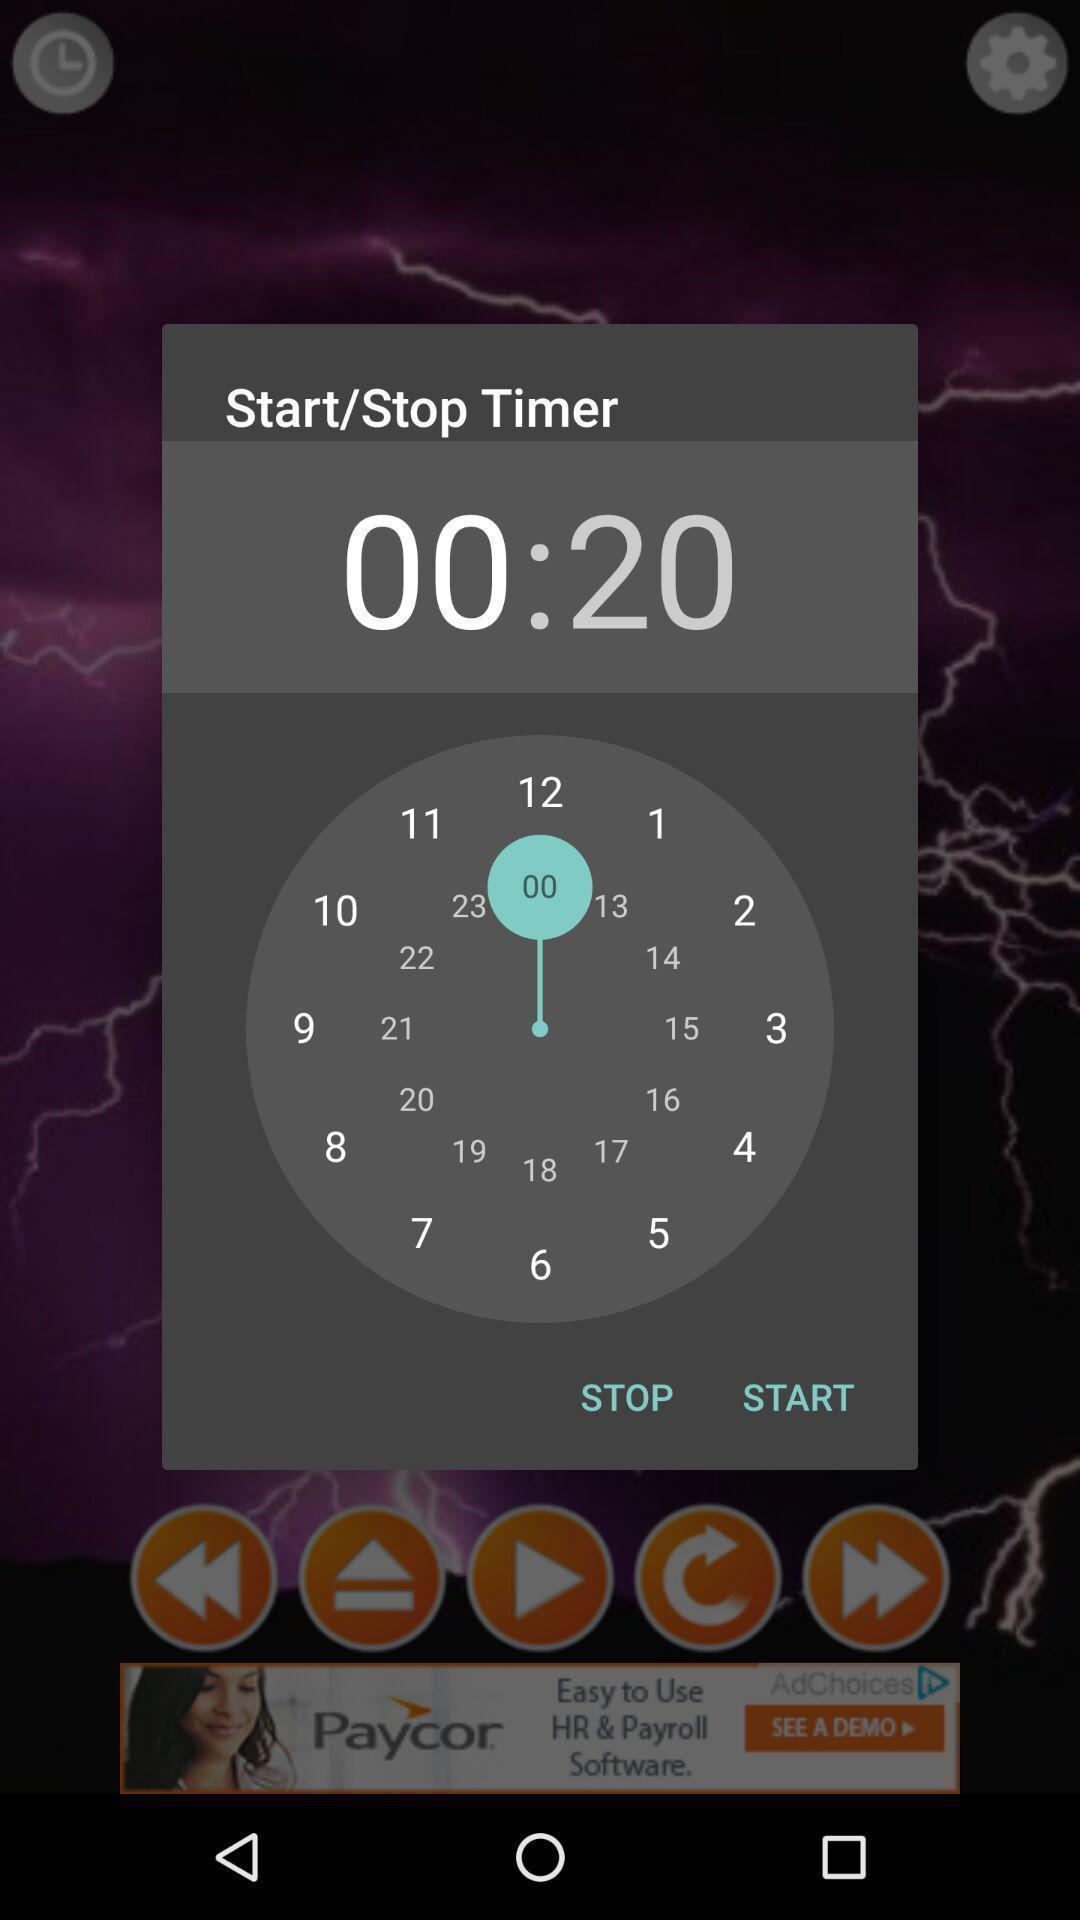Explain the elements present in this screenshot. Pop up showing start/stop timer on an app. 